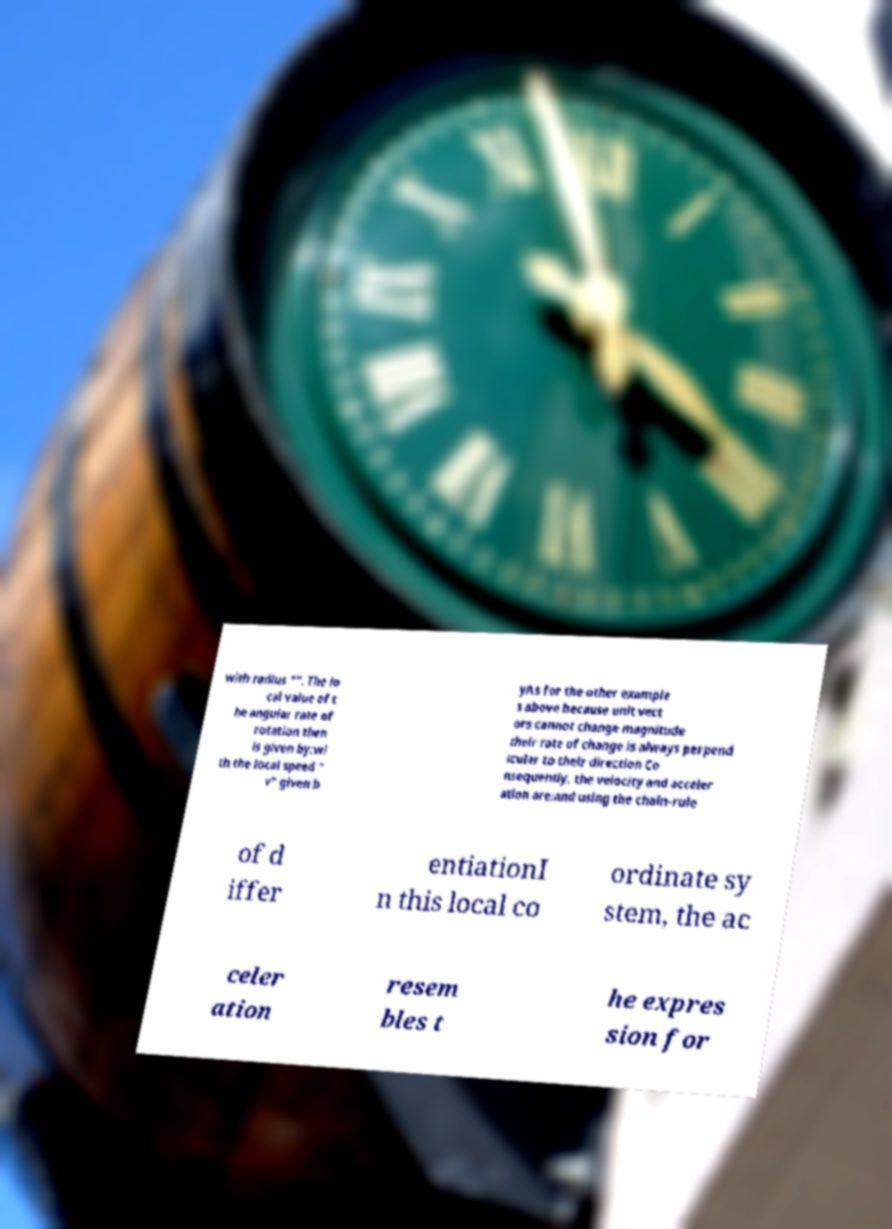Please identify and transcribe the text found in this image. with radius "". The lo cal value of t he angular rate of rotation then is given by:wi th the local speed " v" given b yAs for the other example s above because unit vect ors cannot change magnitude their rate of change is always perpend icular to their direction Co nsequently, the velocity and acceler ation are:and using the chain-rule of d iffer entiationI n this local co ordinate sy stem, the ac celer ation resem bles t he expres sion for 